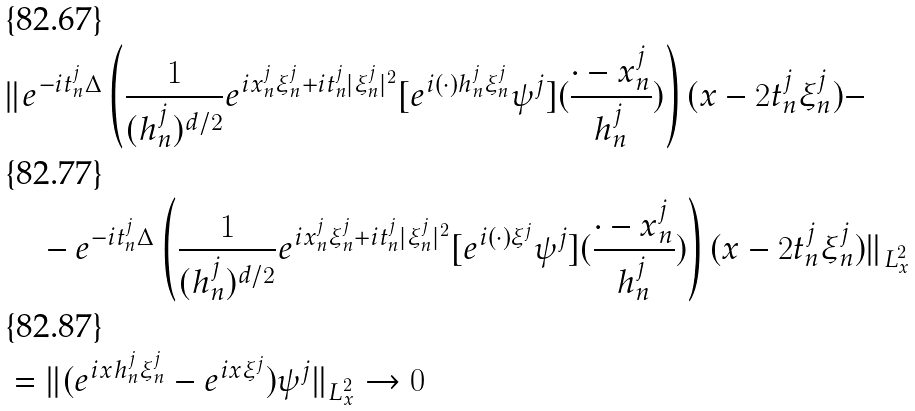<formula> <loc_0><loc_0><loc_500><loc_500>& \| e ^ { - i t _ { n } ^ { j } \Delta } \left ( \frac { 1 } { ( h _ { n } ^ { j } ) ^ { d / 2 } } e ^ { i x _ { n } ^ { j } \xi _ { n } ^ { j } + i t _ { n } ^ { j } | \xi _ { n } ^ { j } | ^ { 2 } } [ e ^ { i ( \cdot ) h _ { n } ^ { j } \xi _ { n } ^ { j } } \psi ^ { j } ] ( \frac { \cdot - x _ { n } ^ { j } } { h _ { n } ^ { j } } ) \right ) ( x - 2 t _ { n } ^ { j } \xi _ { n } ^ { j } ) - \\ & \quad - e ^ { - i t _ { n } ^ { j } \Delta } \left ( \frac { 1 } { ( h _ { n } ^ { j } ) ^ { d / 2 } } e ^ { i x _ { n } ^ { j } \xi _ { n } ^ { j } + i t _ { n } ^ { j } | \xi _ { n } ^ { j } | ^ { 2 } } [ e ^ { i ( \cdot ) \xi ^ { j } } \psi ^ { j } ] ( \frac { \cdot - x _ { n } ^ { j } } { h _ { n } ^ { j } } ) \right ) ( x - 2 t _ { n } ^ { j } \xi _ { n } ^ { j } ) \| _ { L ^ { 2 } _ { x } } \\ & = \| ( e ^ { i x h _ { n } ^ { j } \xi _ { n } ^ { j } } - e ^ { i x \xi ^ { j } } ) \psi ^ { j } \| _ { L ^ { 2 } _ { x } } \to 0</formula> 